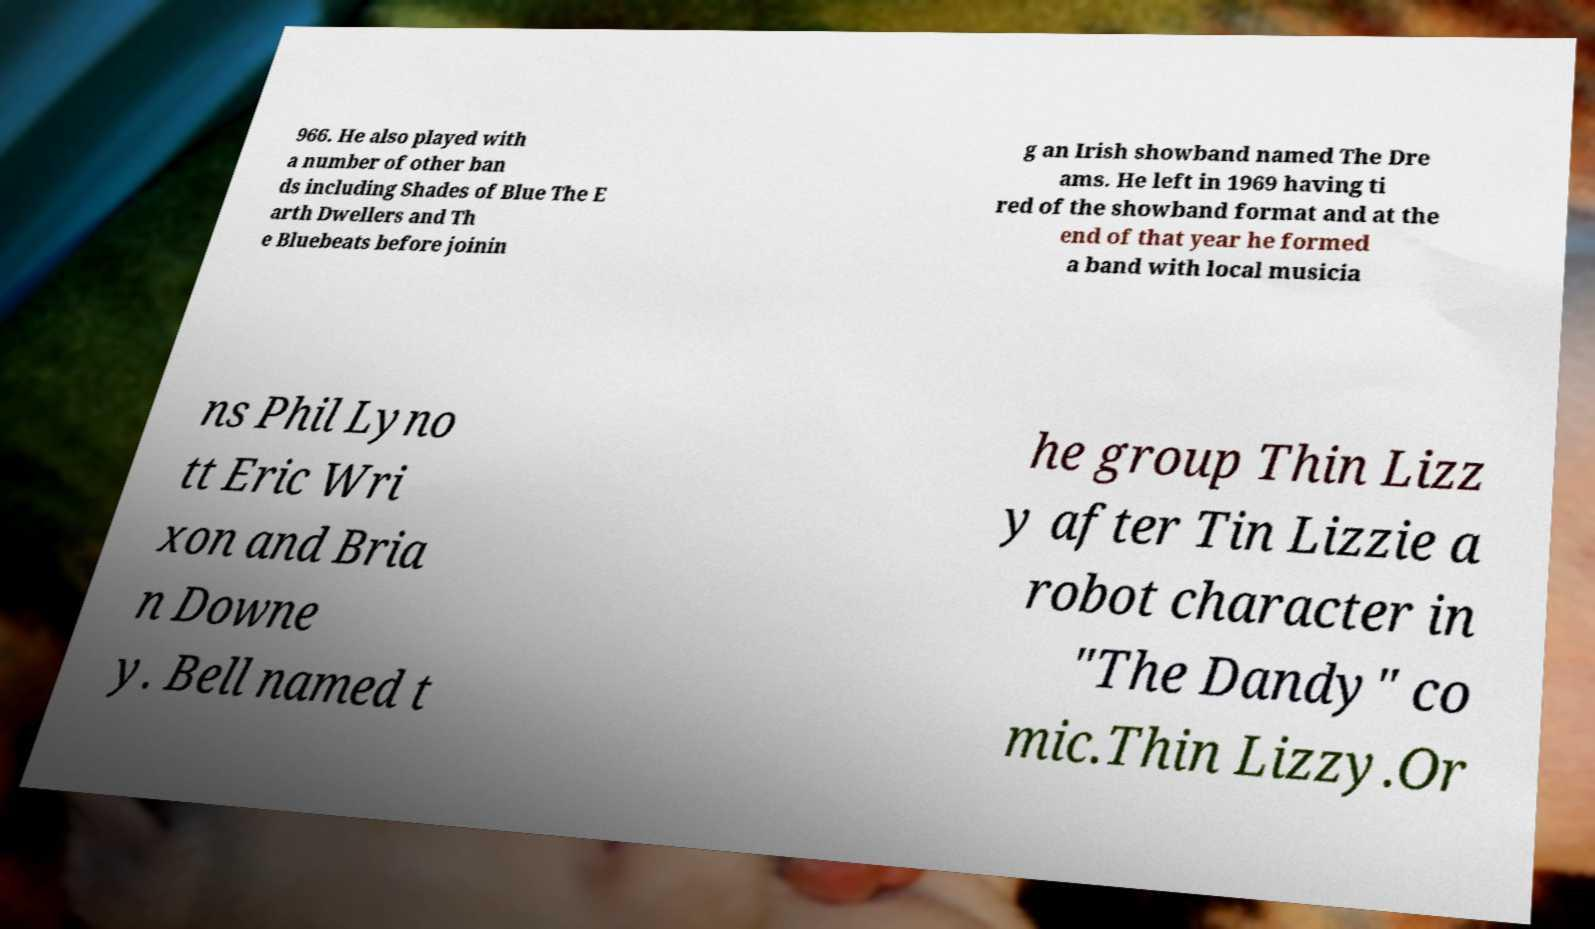Please read and relay the text visible in this image. What does it say? 966. He also played with a number of other ban ds including Shades of Blue The E arth Dwellers and Th e Bluebeats before joinin g an Irish showband named The Dre ams. He left in 1969 having ti red of the showband format and at the end of that year he formed a band with local musicia ns Phil Lyno tt Eric Wri xon and Bria n Downe y. Bell named t he group Thin Lizz y after Tin Lizzie a robot character in "The Dandy" co mic.Thin Lizzy.Or 